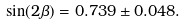Convert formula to latex. <formula><loc_0><loc_0><loc_500><loc_500>\sin ( 2 \beta ) = 0 . 7 3 9 \pm 0 . 0 4 8 .</formula> 